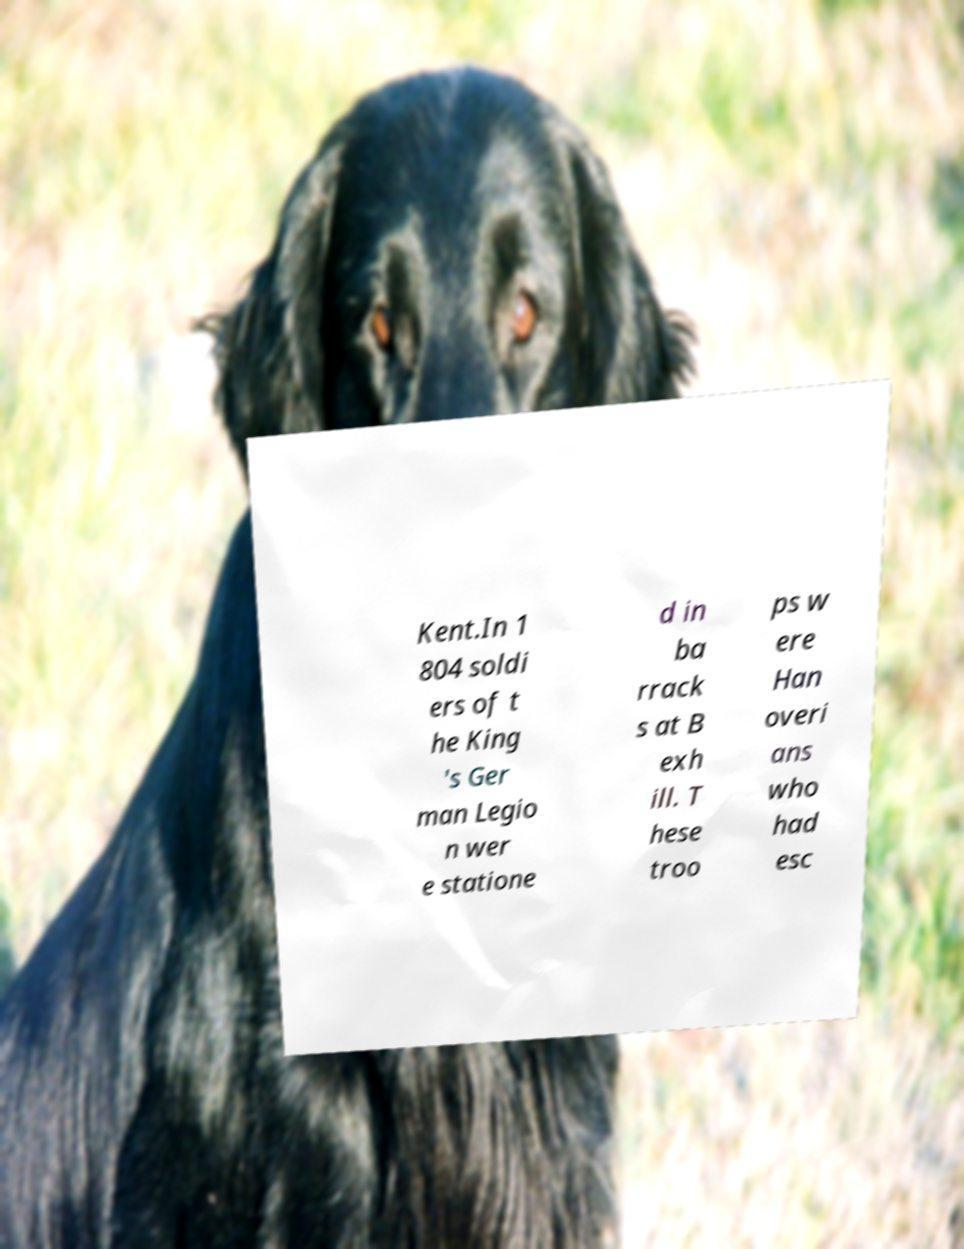Could you assist in decoding the text presented in this image and type it out clearly? Kent.In 1 804 soldi ers of t he King 's Ger man Legio n wer e statione d in ba rrack s at B exh ill. T hese troo ps w ere Han overi ans who had esc 